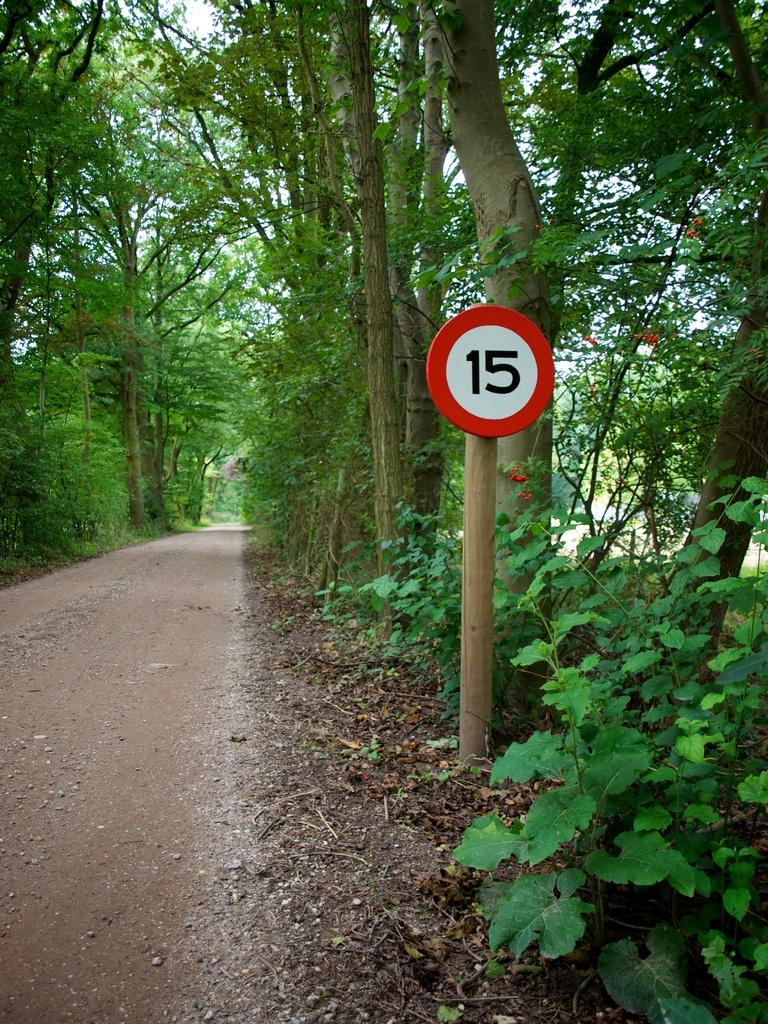<image>
Describe the image concisely. Out on a dirt road, a sign has the number 15 on it. 